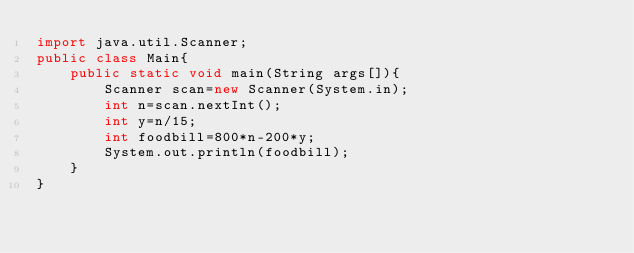<code> <loc_0><loc_0><loc_500><loc_500><_Java_>import java.util.Scanner;
public class Main{
    public static void main(String args[]){
        Scanner scan=new Scanner(System.in);
        int n=scan.nextInt();
        int y=n/15;
        int foodbill=800*n-200*y;
        System.out.println(foodbill);
    }
}</code> 